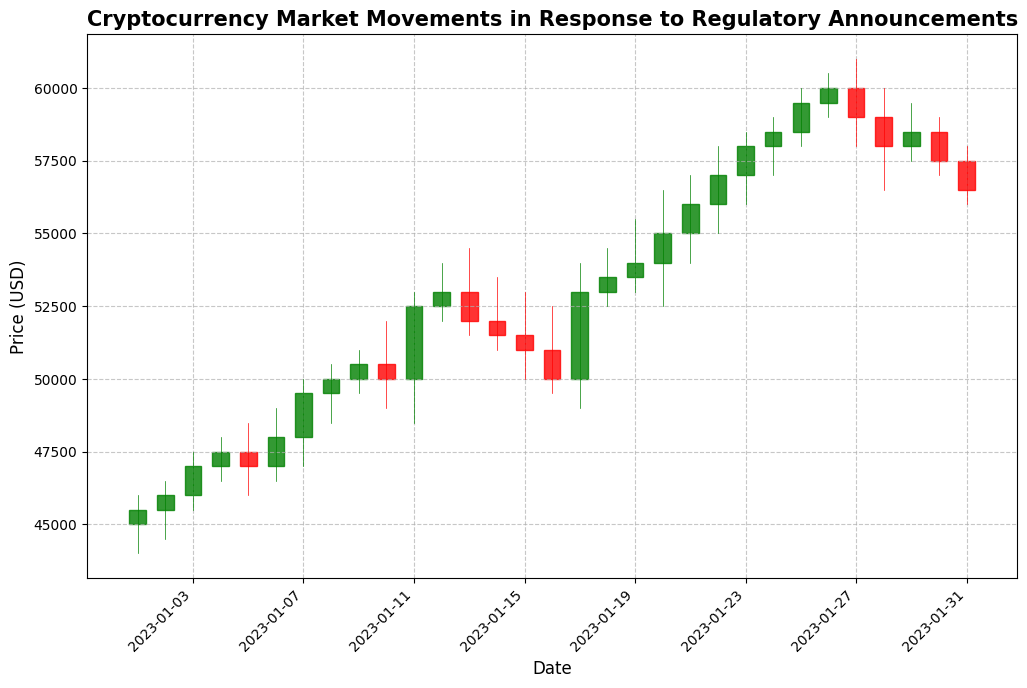What's the trend of the cryptocurrency price from January 1 to January 31? By observing the overall movement of the candlesticks from January 1 to January 31, the general trend shows an upward movement until mid-month, where the price increases significantly, and then the trend stabilizes towards the end of the month.
Answer: Upward then stabilizes How did the price react on January 11? On January 11, the candlestick is green, indicating the price rose. The open price was around 50000, and the closing price was approximately 52500, showing a significant upward movement.
Answer: Increased Which day had the highest closing price? By checking the top of the candlesticks, January 20 has the highest closing price, closing at approximately 55000.
Answer: January 20 What was the difference between the highest and lowest price on January 12? The highest price on January 12 was 54000, and the lowest price was 52000. The difference is calculated by subtracting the lowest price from the highest price: 54000 - 52000 = 2000.
Answer: 2000 How does the volume change on January 24 compare to the volume on January 23? On January 24, the volume was 4900, while on January 23, it was 4800. The volume increased on January 24.
Answer: Increased What visual difference can be observed in the candlestick for the date January 9 compared to January 13? The candlestick of January 9 is green, indicating a price increase, whereas the candlestick of January 13 is red, indicating a price decrease. Additionally, the candlestick for January 13 is longer, suggesting more significant price fluctuation.
Answer: January 9 green, January 13 red, January 13 longer What can be inferred about market volatility from the candlestick on January 20? The candlestick on January 20 is long with noticeable upper and lower shadows, indicating significant price fluctuations within the day, suggesting high market volatility.
Answer: High volatility Which days have the closing price higher than 56000? Observing the candlesticks, the days with closing prices higher than 56000 are January 21, January 22, and January 23, with the closing price well above the 56000 mark.
Answer: January 21, January 22, January 23 What's the average closing price for the last week of January? The closing prices for the last week of January (January 25 to January 31) are 59500, 60000, 59000, 58000, 58500, 57500, and 56500. The average is calculated as (59500 + 60000 + 59000 + 58000 + 58500 + 57500 + 56500) / 7 = 58428.57.
Answer: 58428.57 